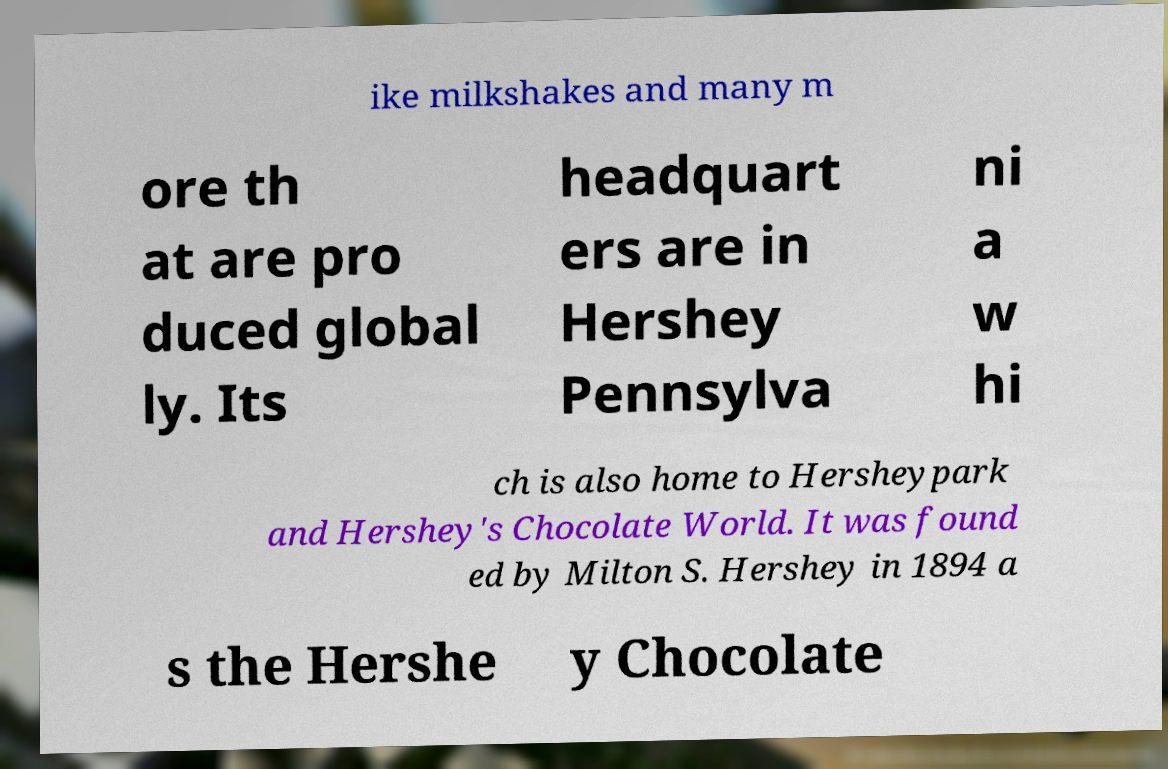Can you accurately transcribe the text from the provided image for me? ike milkshakes and many m ore th at are pro duced global ly. Its headquart ers are in Hershey Pennsylva ni a w hi ch is also home to Hersheypark and Hershey's Chocolate World. It was found ed by Milton S. Hershey in 1894 a s the Hershe y Chocolate 